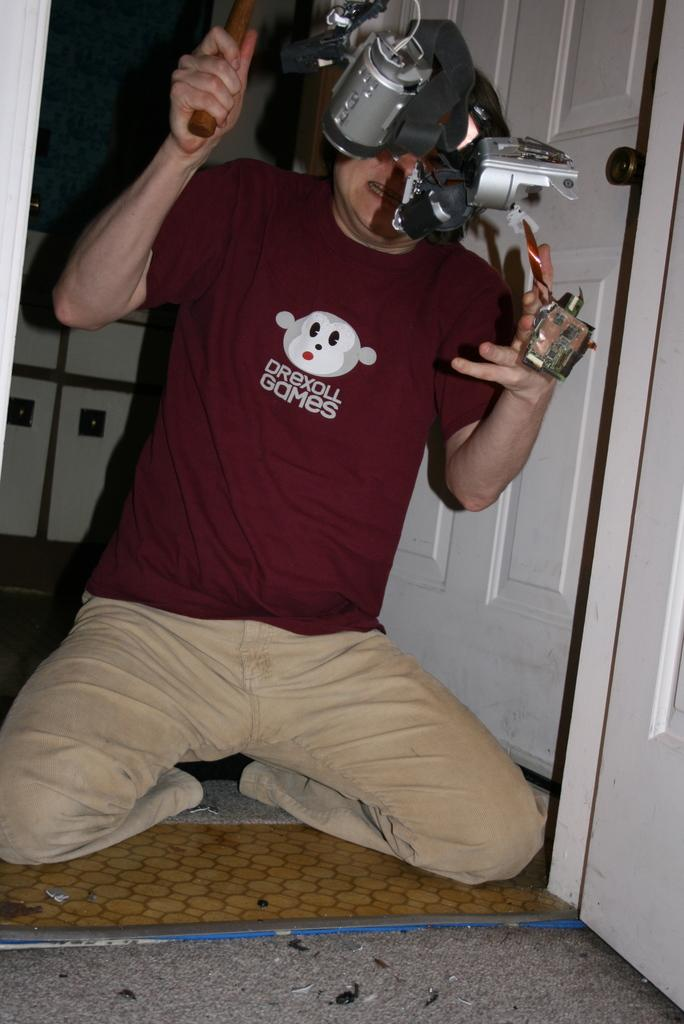What is one of the main objects in the image? There is a door in the image. What else can be seen in the image besides the door? There is an electrical equipment and a person in the image. Can you describe the person in the image? The person is wearing a red color t-shirt. How many silver frogs are sitting on the electrical equipment in the image? There are no frogs, silver or otherwise, present on the electrical equipment in the image. 